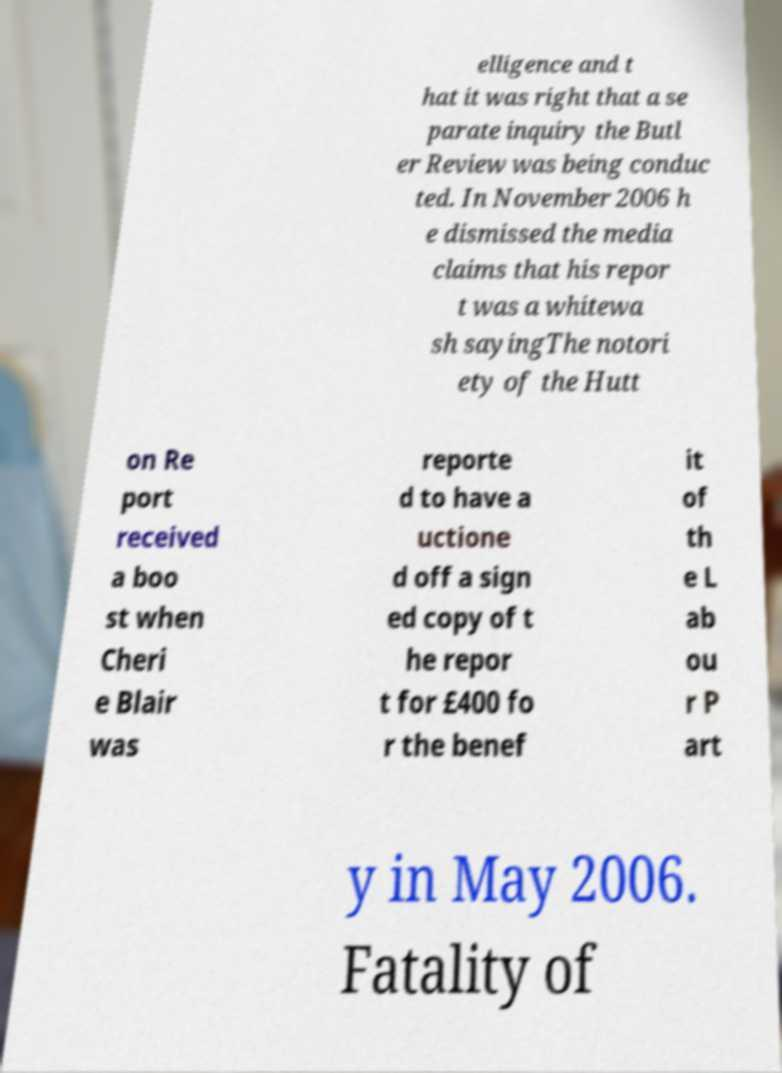What messages or text are displayed in this image? I need them in a readable, typed format. elligence and t hat it was right that a se parate inquiry the Butl er Review was being conduc ted. In November 2006 h e dismissed the media claims that his repor t was a whitewa sh sayingThe notori ety of the Hutt on Re port received a boo st when Cheri e Blair was reporte d to have a uctione d off a sign ed copy of t he repor t for £400 fo r the benef it of th e L ab ou r P art y in May 2006. Fatality of 